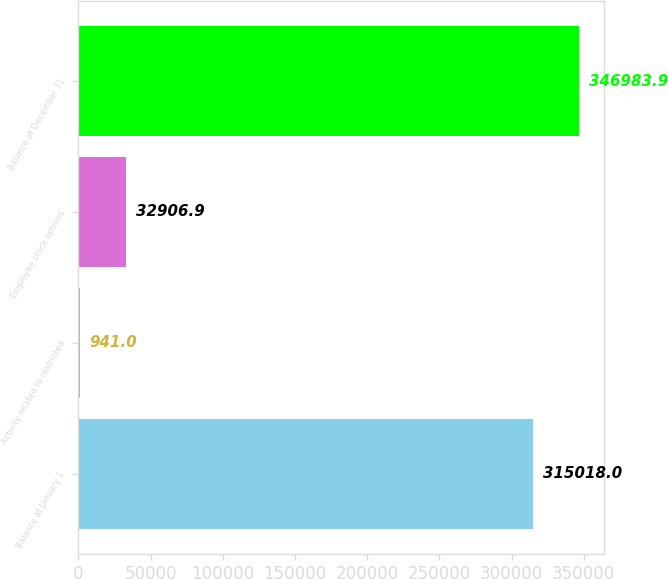<chart> <loc_0><loc_0><loc_500><loc_500><bar_chart><fcel>Balance at January 1<fcel>Activity related to restricted<fcel>Employee stock options<fcel>Balance at December 31<nl><fcel>315018<fcel>941<fcel>32906.9<fcel>346984<nl></chart> 